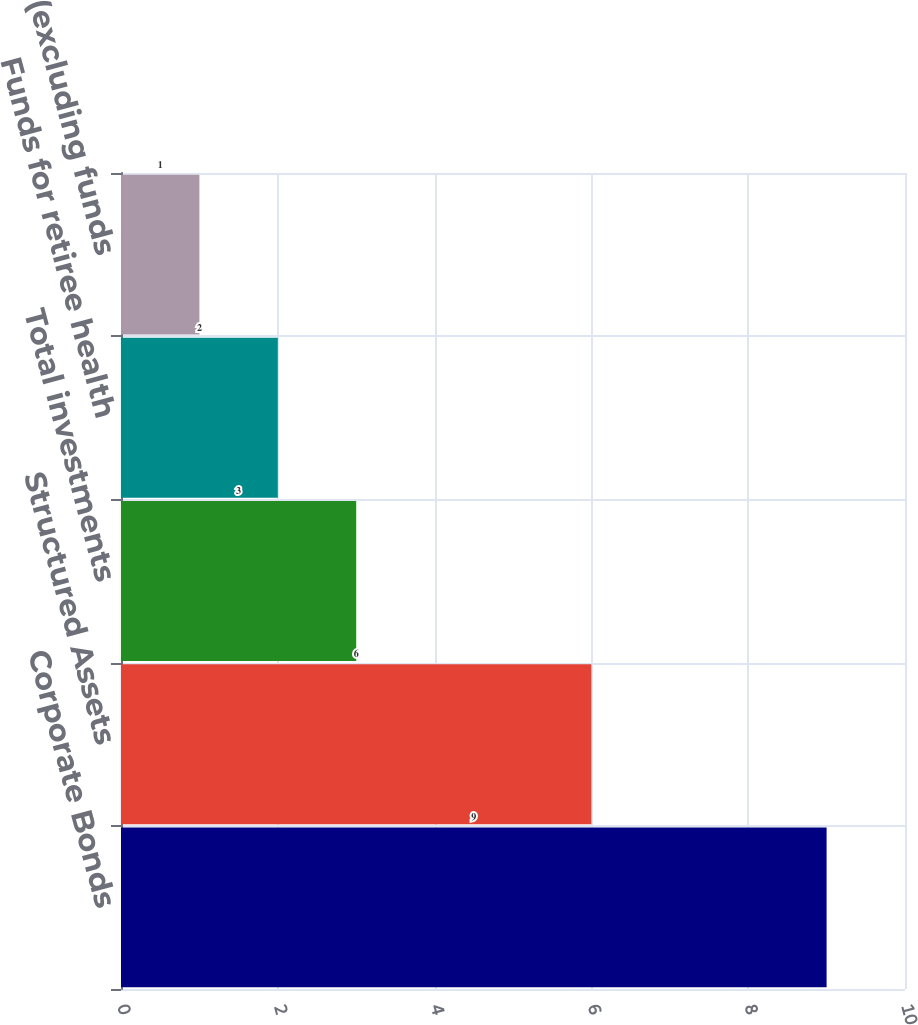Convert chart. <chart><loc_0><loc_0><loc_500><loc_500><bar_chart><fcel>Corporate Bonds<fcel>Structured Assets<fcel>Total investments<fcel>Funds for retiree health<fcel>Investments (excluding funds<nl><fcel>9<fcel>6<fcel>3<fcel>2<fcel>1<nl></chart> 